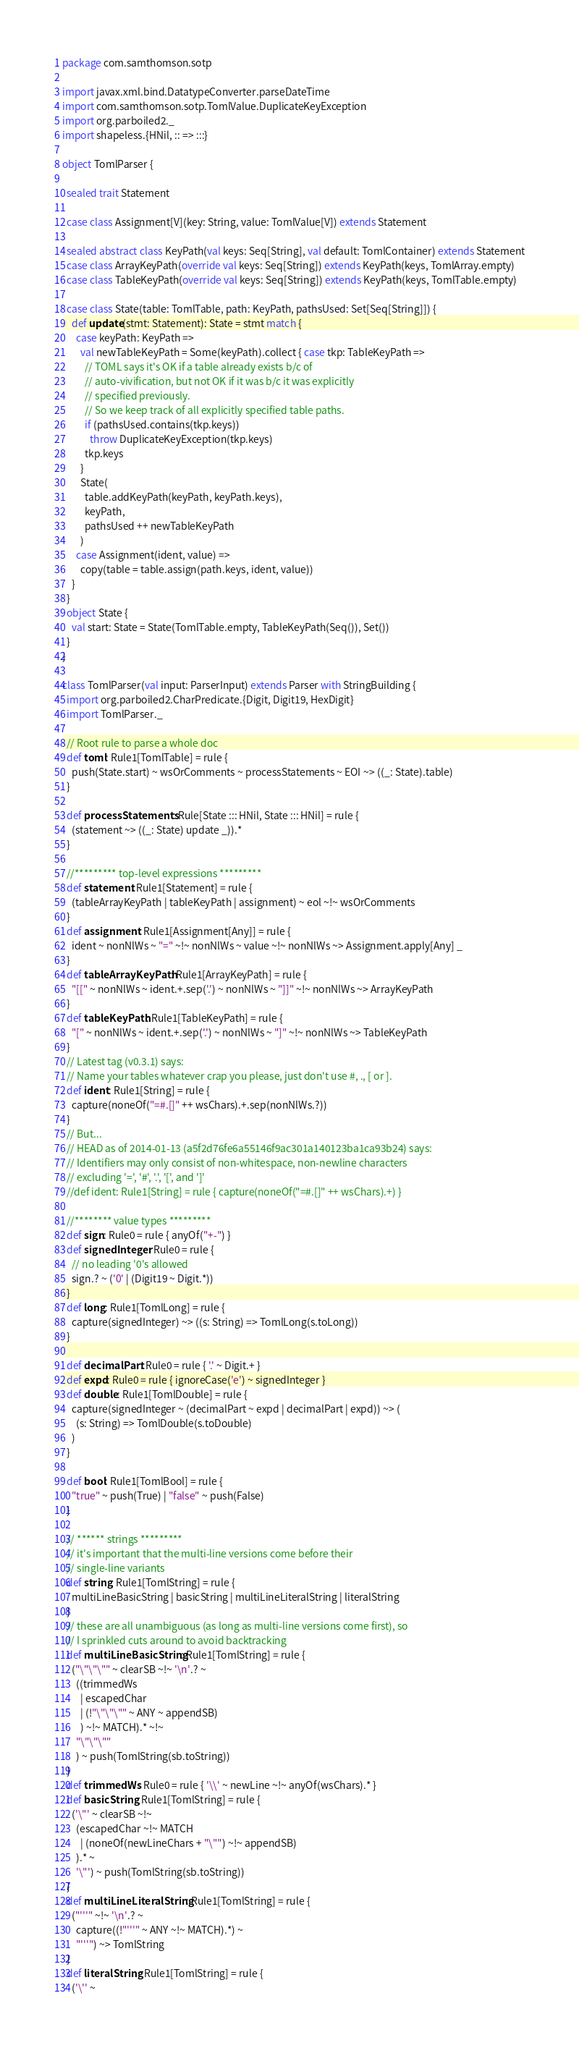Convert code to text. <code><loc_0><loc_0><loc_500><loc_500><_Scala_>package com.samthomson.sotp

import javax.xml.bind.DatatypeConverter.parseDateTime
import com.samthomson.sotp.TomlValue.DuplicateKeyException
import org.parboiled2._
import shapeless.{HNil, :: => :::}

object TomlParser {

  sealed trait Statement

  case class Assignment[V](key: String, value: TomlValue[V]) extends Statement

  sealed abstract class KeyPath(val keys: Seq[String], val default: TomlContainer) extends Statement
  case class ArrayKeyPath(override val keys: Seq[String]) extends KeyPath(keys, TomlArray.empty)
  case class TableKeyPath(override val keys: Seq[String]) extends KeyPath(keys, TomlTable.empty)

  case class State(table: TomlTable, path: KeyPath, pathsUsed: Set[Seq[String]]) {
    def update(stmt: Statement): State = stmt match {
      case keyPath: KeyPath =>
        val newTableKeyPath = Some(keyPath).collect { case tkp: TableKeyPath =>
          // TOML says it's OK if a table already exists b/c of
          // auto-vivification, but not OK if it was b/c it was explicitly
          // specified previously.
          // So we keep track of all explicitly specified table paths.
          if (pathsUsed.contains(tkp.keys))
            throw DuplicateKeyException(tkp.keys)
          tkp.keys
        }
        State(
          table.addKeyPath(keyPath, keyPath.keys),
          keyPath,
          pathsUsed ++ newTableKeyPath
        )
      case Assignment(ident, value) =>
        copy(table = table.assign(path.keys, ident, value))
    }
  }
  object State {
    val start: State = State(TomlTable.empty, TableKeyPath(Seq()), Set())
  }
}

class TomlParser(val input: ParserInput) extends Parser with StringBuilding {
  import org.parboiled2.CharPredicate.{Digit, Digit19, HexDigit}
  import TomlParser._

  // Root rule to parse a whole doc
  def toml: Rule1[TomlTable] = rule {
    push(State.start) ~ wsOrComments ~ processStatements ~ EOI ~> ((_: State).table)
  }

  def processStatements: Rule[State ::: HNil, State ::: HNil] = rule {
    (statement ~> ((_: State) update _)).*
  }

  //********* top-level expressions *********
  def statement: Rule1[Statement] = rule {
    (tableArrayKeyPath | tableKeyPath | assignment) ~ eol ~!~ wsOrComments
  }
  def assignment: Rule1[Assignment[Any]] = rule {
    ident ~ nonNlWs ~ "=" ~!~ nonNlWs ~ value ~!~ nonNlWs ~> Assignment.apply[Any] _
  }
  def tableArrayKeyPath: Rule1[ArrayKeyPath] = rule {
    "[[" ~ nonNlWs ~ ident.+.sep('.') ~ nonNlWs ~ "]]" ~!~ nonNlWs ~> ArrayKeyPath
  }
  def tableKeyPath: Rule1[TableKeyPath] = rule {
    "[" ~ nonNlWs ~ ident.+.sep('.') ~ nonNlWs ~ "]" ~!~ nonNlWs ~> TableKeyPath
  }
  // Latest tag (v0.3.1) says:
  // Name your tables whatever crap you please, just don't use #, ., [ or ].
  def ident: Rule1[String] = rule {
    capture(noneOf("=#.[]" ++ wsChars).+.sep(nonNlWs.?))
  }
  // But...
  // HEAD as of 2014-01-13 (a5f2d76fe6a55146f9ac301a140123ba1ca93b24) says:
  // Identifiers may only consist of non-whitespace, non-newline characters
  // excluding '=', '#', '.', '[', and ']'
  //def ident: Rule1[String] = rule { capture(noneOf("=#.[]" ++ wsChars).+) }

  //******** value types *********
  def sign: Rule0 = rule { anyOf("+-") }
  def signedInteger: Rule0 = rule {
    // no leading '0's allowed
    sign.? ~ ('0' | (Digit19 ~ Digit.*))
  }
  def long: Rule1[TomlLong] = rule {
    capture(signedInteger) ~> ((s: String) => TomlLong(s.toLong))
  }

  def decimalPart: Rule0 = rule { '.' ~ Digit.+ }
  def expd: Rule0 = rule { ignoreCase('e') ~ signedInteger }
  def double: Rule1[TomlDouble] = rule {
    capture(signedInteger ~ (decimalPart ~ expd | decimalPart | expd)) ~> (
      (s: String) => TomlDouble(s.toDouble)
    )
  }

  def bool: Rule1[TomlBool] = rule {
    "true" ~ push(True) | "false" ~ push(False)
  }

  // ****** strings *********
  // it's important that the multi-line versions come before their
  // single-line variants
  def string: Rule1[TomlString] = rule {
    multiLineBasicString | basicString | multiLineLiteralString | literalString
  }
  // these are all unambiguous (as long as multi-line versions come first), so
  // I sprinkled cuts around to avoid backtracking
  def multiLineBasicString: Rule1[TomlString] = rule {
    ("\"\"\"" ~ clearSB ~!~ '\n'.? ~
      ((trimmedWs
        | escapedChar
        | (!"\"\"\"" ~ ANY ~ appendSB)
        ) ~!~ MATCH).* ~!~
      "\"\"\""
      ) ~ push(TomlString(sb.toString))
  }
  def trimmedWs: Rule0 = rule { '\\' ~ newLine ~!~ anyOf(wsChars).* }
  def basicString: Rule1[TomlString] = rule {
    ('\"' ~ clearSB ~!~
      (escapedChar ~!~ MATCH
        | (noneOf(newLineChars + "\"") ~!~ appendSB)
      ).* ~
      '\"') ~ push(TomlString(sb.toString))
  }
  def multiLineLiteralString: Rule1[TomlString] = rule {
    ("'''" ~!~ '\n'.? ~
      capture((!"'''" ~ ANY ~!~ MATCH).*) ~
      "'''") ~> TomlString
  }
  def literalString: Rule1[TomlString] = rule {
    ('\'' ~</code> 